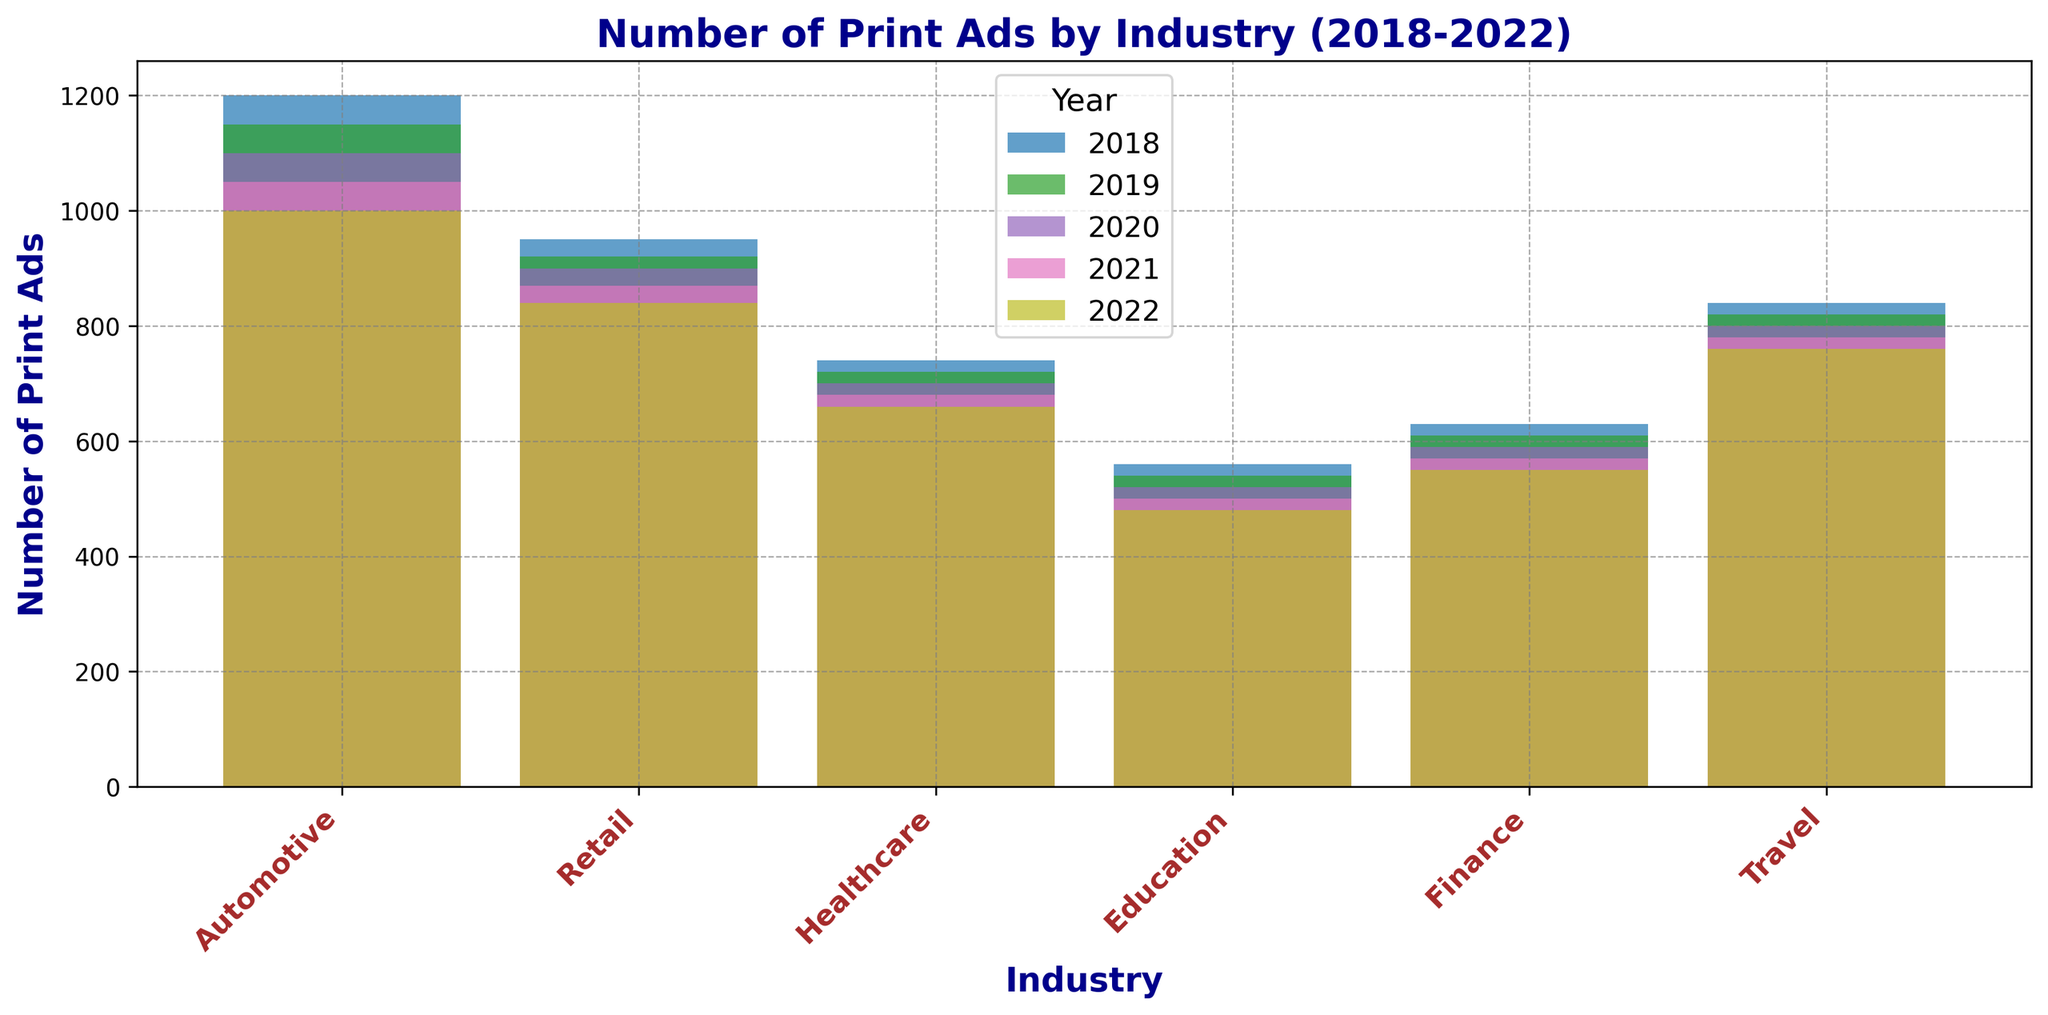What was the total number of print ads placed by the Automotive industry from 2018 to 2022? Add the number of print ads for the Automotive industry from all years shown in the figure. It will be 1200 + 1150 + 1100 + 1050 + 1000 = 5500
Answer: 5500 Which industry had the highest number of print ads in 2022? Look for the tallest bar in the 2022 grouping. The Automotive industry's bar is tallest in that group.
Answer: Automotive How did the number of print ads in the Retail industry change from 2018 to 2022? Compare the height of the Retail industry's bars for 2018 and 2022. The number decreased from 950 in 2018 to 840 in 2022.
Answer: Decreased Which year had the lowest overall number of print ads across all industries? Compare the combined heights (or visually sum) of the bars for each year. 2022 has the lowest overall height of bars when summed up visually.
Answer: 2022 What is the difference in the number of print ads between the Automotive and Travel industries in 2020? Look at the heights of the bars corresponding to Automotive and Travel for 2020 and find the difference. It’s 1100 - 800 = 300.
Answer: 300 Which industry showed the most consistent number of print ads from 2018 to 2022? Check for the industry bars that remain most similar in height throughout the years. The Healthcare industry has consistently minor changes in the number of print ads: 740, 720, 700, 680, 660.
Answer: Healthcare What is the average number of print ads placed by the Travel industry per year from 2018 to 2022? Add the number of print ads for the Travel industry for all the years and divide by 5 (number of years). (840 + 820 + 800 + 780 + 760) / 5 = 4000 / 5 = 800.
Answer: 800 Which year had the highest number of print ads in the Finance industry? Look at the heights of the Finance industry's bars and identify the tallest. The year 2018 (630 ads) is the highest.
Answer: 2018 Which two industries had the closest number of print ads in 2021? Compare the heights of all the bars in 2021 to find the smallest difference between two bars. Finance (570) and Education (500) are the closest.
Answer: Finance and Education By how much did the number of print ads in the Education industry decrease from 2018 to 2022? Subtract the number of ads for the Education industry in 2022 from the number in 2018. 560 - 480 = 80
Answer: 80 